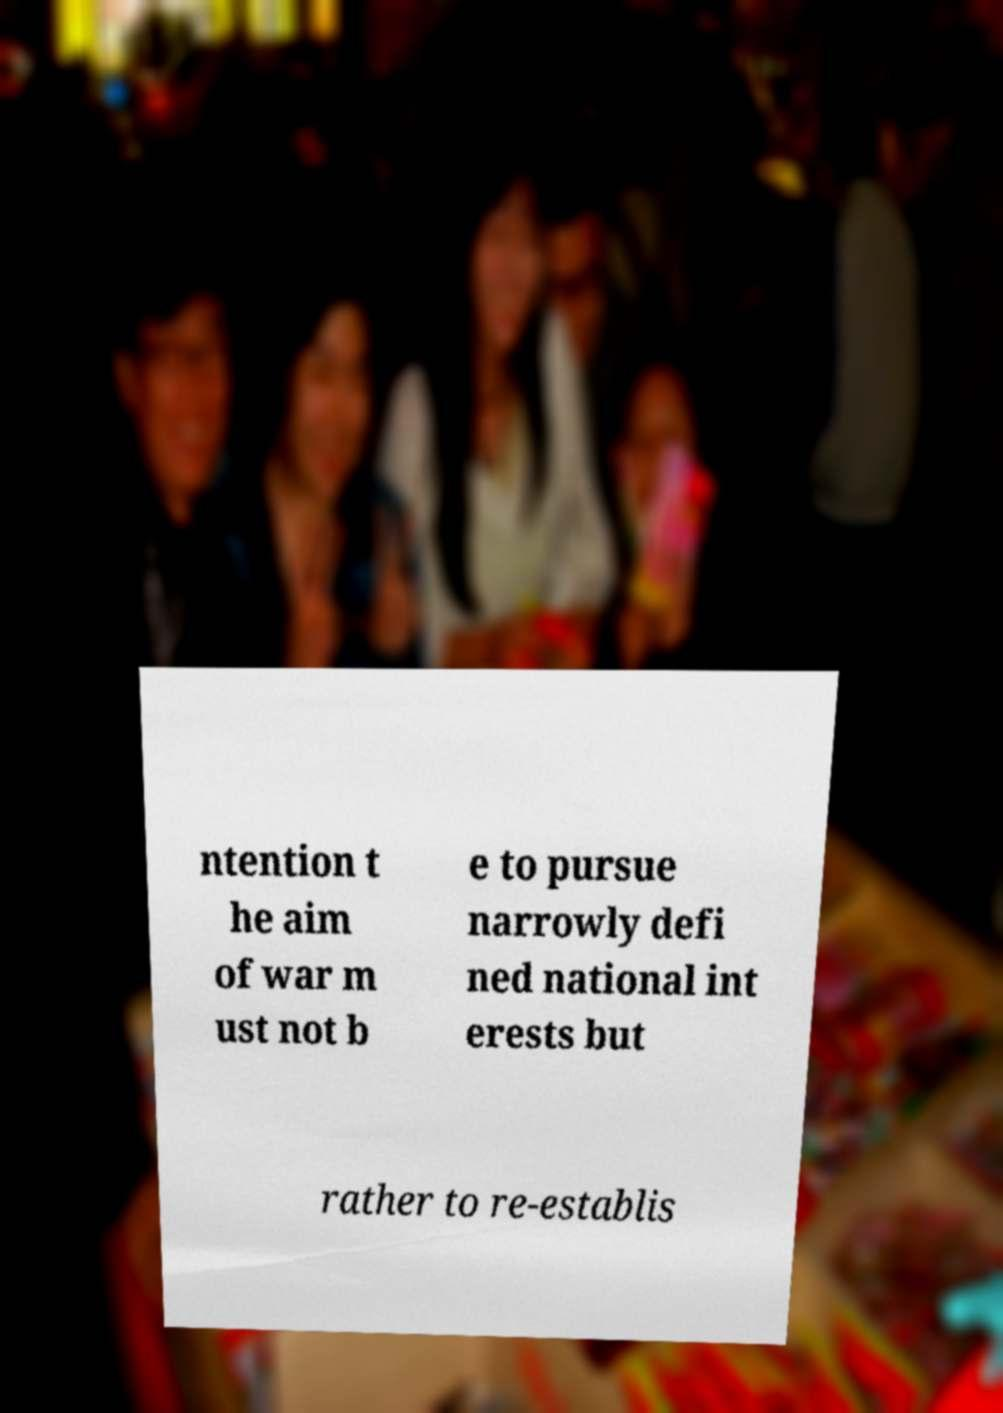Please read and relay the text visible in this image. What does it say? ntention t he aim of war m ust not b e to pursue narrowly defi ned national int erests but rather to re-establis 